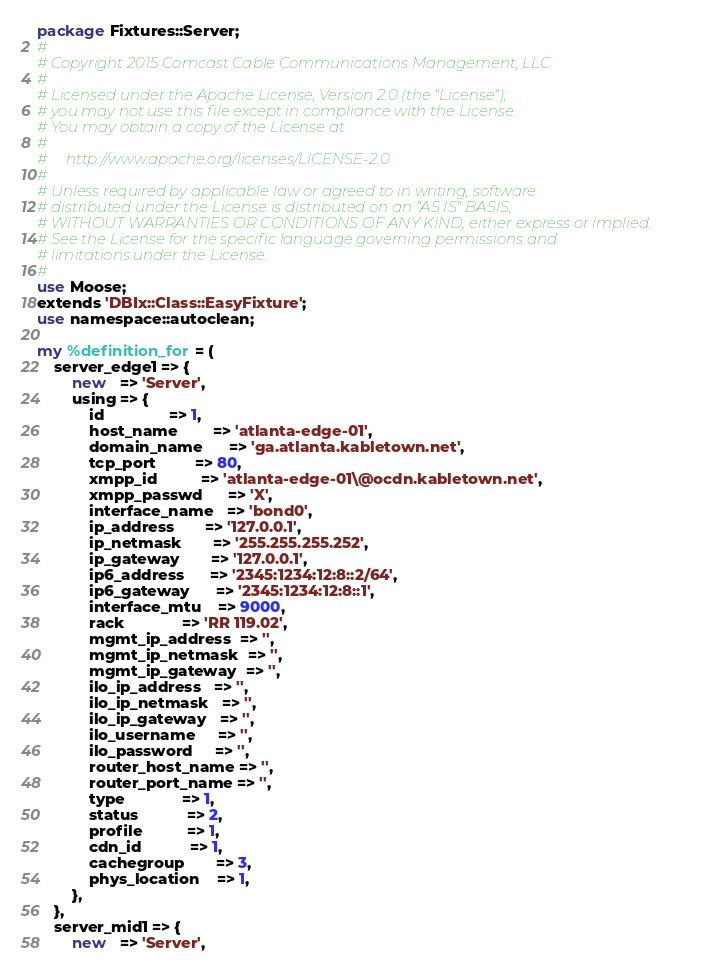<code> <loc_0><loc_0><loc_500><loc_500><_Perl_>package Fixtures::Server;
#
# Copyright 2015 Comcast Cable Communications Management, LLC
#
# Licensed under the Apache License, Version 2.0 (the "License");
# you may not use this file except in compliance with the License.
# You may obtain a copy of the License at
#
#     http://www.apache.org/licenses/LICENSE-2.0
#
# Unless required by applicable law or agreed to in writing, software
# distributed under the License is distributed on an "AS IS" BASIS,
# WITHOUT WARRANTIES OR CONDITIONS OF ANY KIND, either express or implied.
# See the License for the specific language governing permissions and
# limitations under the License.
#
use Moose;
extends 'DBIx::Class::EasyFixture';
use namespace::autoclean;

my %definition_for = (
	server_edge1 => {
		new   => 'Server',
		using => {
			id               => 1,
			host_name        => 'atlanta-edge-01',
			domain_name      => 'ga.atlanta.kabletown.net',
			tcp_port         => 80,
			xmpp_id          => 'atlanta-edge-01\@ocdn.kabletown.net',
			xmpp_passwd      => 'X',
			interface_name   => 'bond0',
			ip_address       => '127.0.0.1',
			ip_netmask       => '255.255.255.252',
			ip_gateway       => '127.0.0.1',
			ip6_address      => '2345:1234:12:8::2/64',
			ip6_gateway      => '2345:1234:12:8::1',
			interface_mtu    => 9000,
			rack             => 'RR 119.02',
			mgmt_ip_address  => '',
			mgmt_ip_netmask  => '',
			mgmt_ip_gateway  => '',
			ilo_ip_address   => '',
			ilo_ip_netmask   => '',
			ilo_ip_gateway   => '',
			ilo_username     => '',
			ilo_password     => '',
			router_host_name => '',
			router_port_name => '',
			type             => 1,
			status           => 2,
			profile          => 1,
			cdn_id           => 1,
			cachegroup       => 3,
			phys_location    => 1,
		},
	},
	server_mid1 => {
		new   => 'Server',</code> 